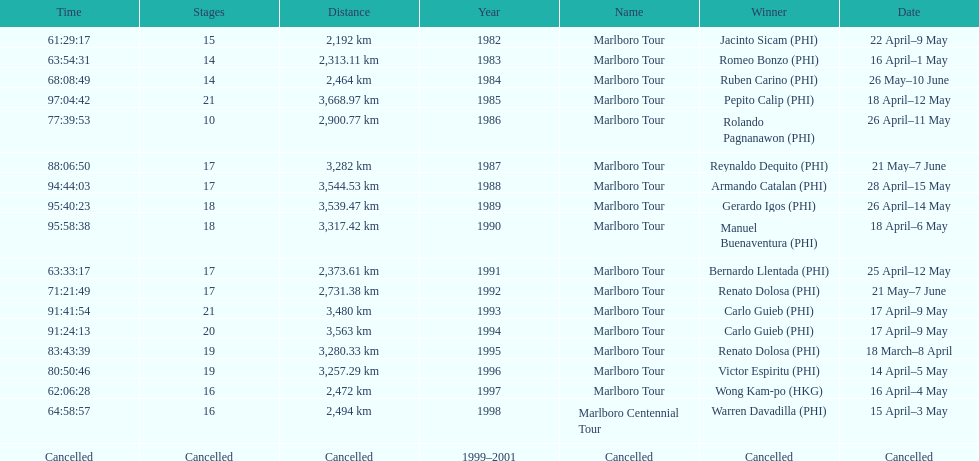Who won the most marlboro tours? Carlo Guieb. 